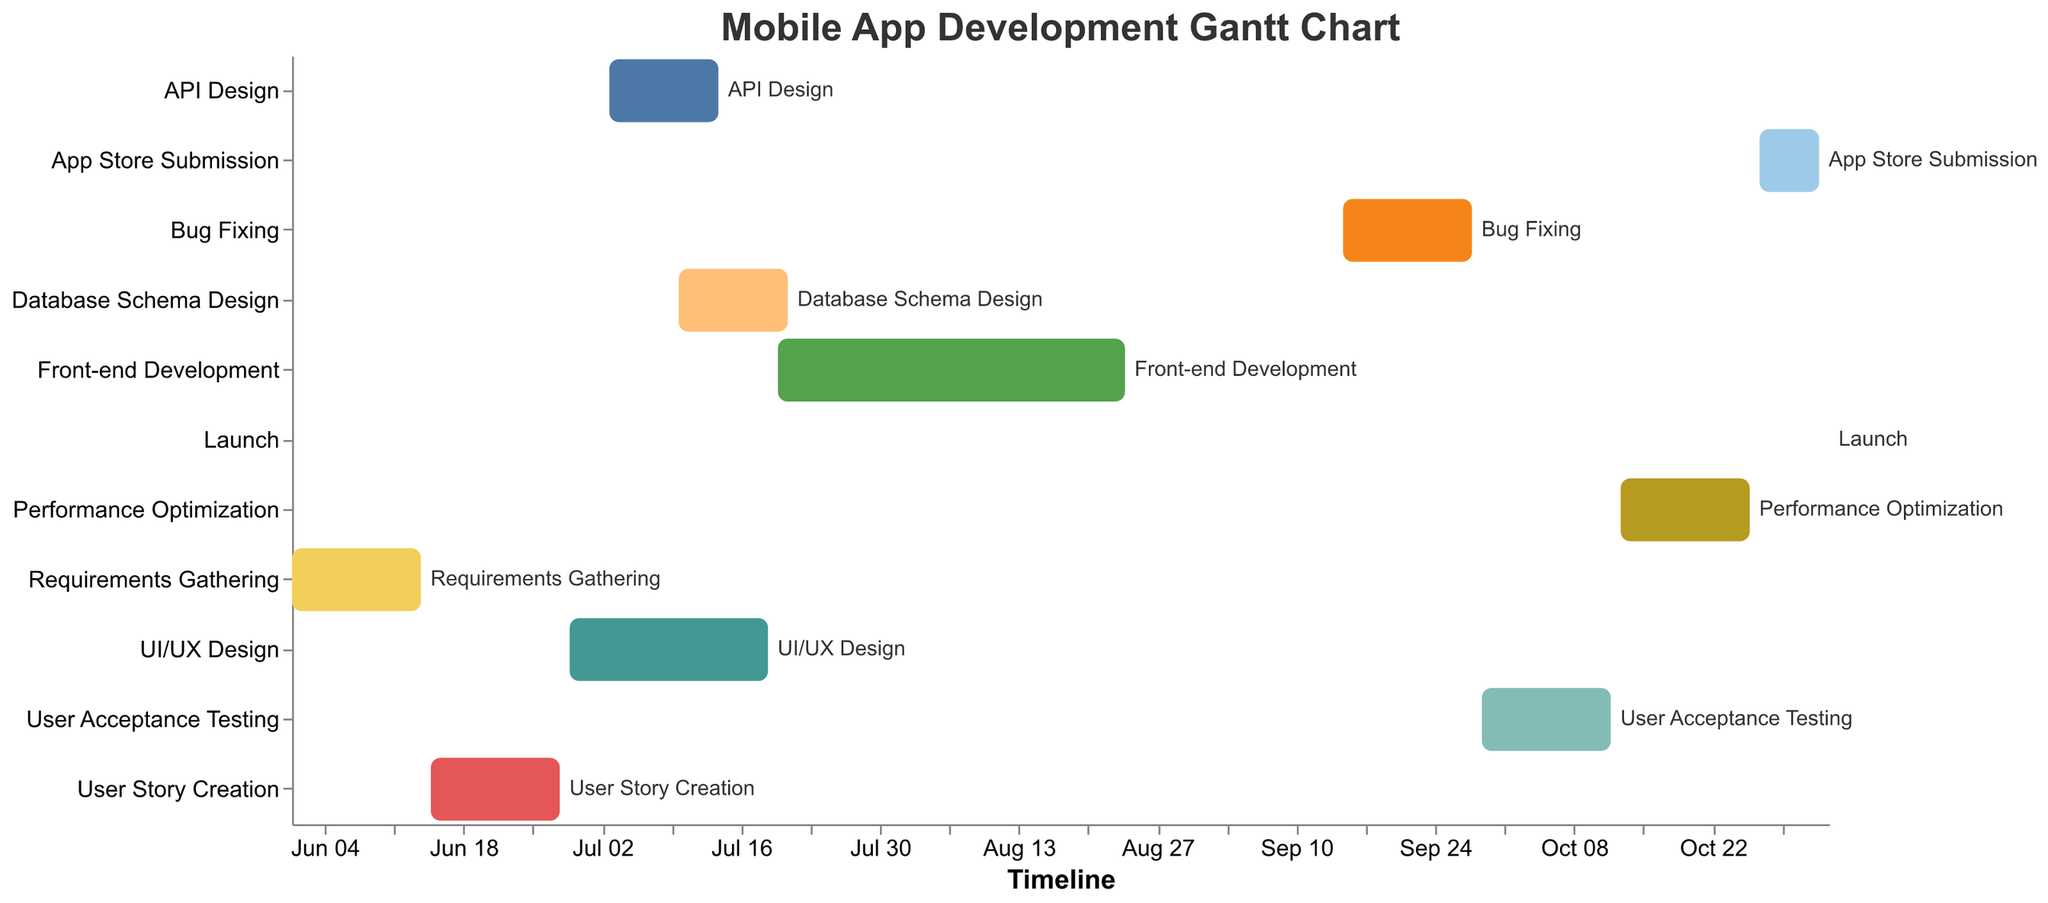What is the title of the Gantt chart? The title is usually located at the top of the chart and clearly indicates what the chart is about. Here, it states "Mobile App Development Gantt Chart".
Answer: Mobile App Development Gantt Chart Which task starts first in the project? The first task is the one with the earliest start date. From the chart, "Requirements Gathering" starts on 2023-06-01, which is the earliest date.
Answer: Requirements Gathering How many tasks are completely dependent on the completion of "User Story Creation"? To find the dependent tasks, look for the ones where "User Story Creation" is listed under Dependencies. "UI/UX Design" and "API Design" are two tasks dependent on it.
Answer: 2 What is the duration of the "Front-end Development" phase? The duration can be calculated by subtracting the start date from the end date. "Front-end Development" starts on 2023-07-20 and ends on 2023-08-24, so the duration is 35 days.
Answer: 35 days Which task has the shortest duration? Compare the start and end dates of each task and find the one with the least difference. "Launch" has the shortest duration as it starts and ends on the same day, 2023-11-03.
Answer: Launch Which task follows immediately after "Bug Fixing"? Check the dependencies field to see what comes directly after "Bug Fixing". "User Acceptance Testing" follows "Bug Fixing".
Answer: User Acceptance Testing What is the total duration of the project? The total duration is the difference between the start date of the first task and the end date of the last task. The project starts on 2023-06-01 ("Requirements Gathering") and ends on 2023-11-03 ("Launch"), so the duration is 156 days.
Answer: 156 days Is "API Design" dependent on "UI/UX Design"? Look at the Dependencies field of "API Design". It lists "User Story Creation" as its dependency, not "UI/UX Design".
Answer: No How many tasks are planned to occur in September 2023? Identify tasks with dates falling in September 2023: "Bug Fixing" (2023-09-15 to 2023-09-28) and "User Acceptance Testing" (starts on 2023-09-29) are both in September.
Answer: 2 Which task has the most dependencies? Check the Dependencies field of each task. Most tasks have one dependency, but none have more than one listed. Thus, no task has the most dependencies compared to others.
Answer: None 